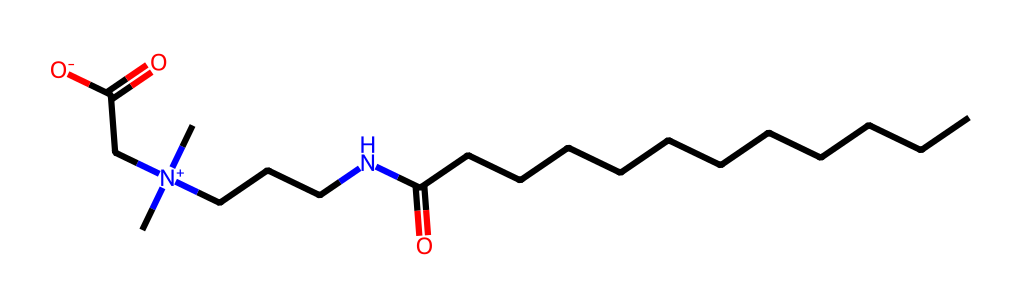What type of surfactant is represented by this chemical? This chemical's structure shows both a hydrophobic tail (long carbon chain) and a hydrophilic head (the zwitterionic part with positive and negative charges), which are characteristic of zwitterionic surfactants.
Answer: zwitterionic How many carbon atoms are in this molecule? By examining the chemical structure, I count a straight chain of twelve carbon atoms (from the long carbon chain) and additional carbons in the amine (two from N) for a total of fifteen carbon atoms.
Answer: fifteen What functional groups are present in this chemical? Looking at the structure, I can identify a carboxylic acid group from the terminal -C(=O)OH and an ammonium group (positive nitrogen with attached organic chains).
Answer: carboxylic acid, ammonium Is this surfactant likely to be soluble in water? Due to the presence of the zwitterionic structure and the ionic nature of the functional groups, which enhance interactions with water, this surfactant is likely to be soluble in water.
Answer: yes What role do zwitterionic surfactants play in personal care products in zero-gravity? In zero-gravity, the enhanced stability and reduced surface tension effects of zwitterionic surfactants help in even distribution and effective cleansing in personal care products, which is essential where water behaves differently.
Answer: stability and cleansing Does this molecule possess a net charge? The zwitterionic nature of the molecule implicates that it contains both a positive charge and a negative charge, thus resulting in a net charge of zero overall.
Answer: no 